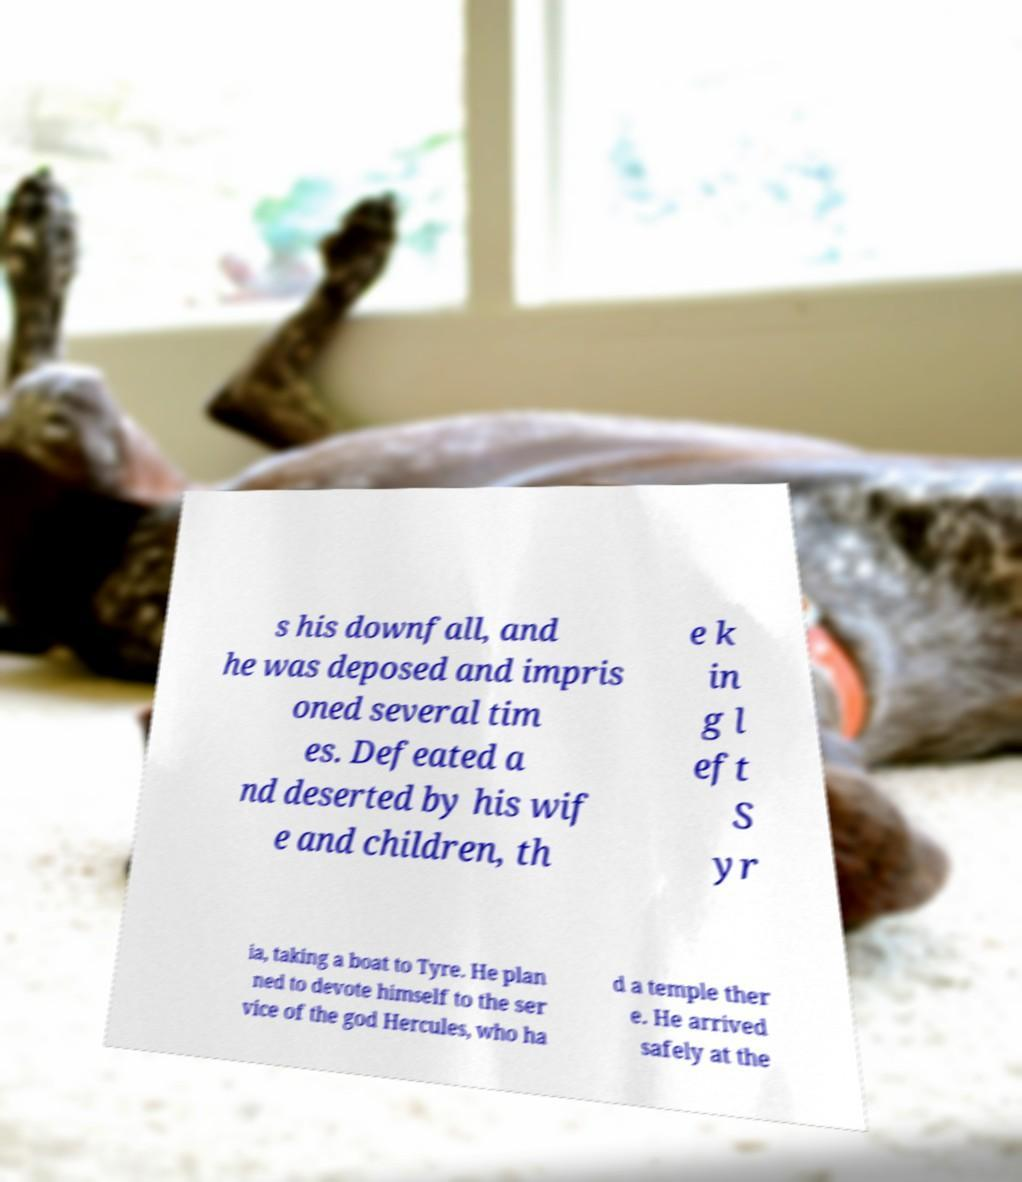Please read and relay the text visible in this image. What does it say? s his downfall, and he was deposed and impris oned several tim es. Defeated a nd deserted by his wif e and children, th e k in g l eft S yr ia, taking a boat to Tyre. He plan ned to devote himself to the ser vice of the god Hercules, who ha d a temple ther e. He arrived safely at the 